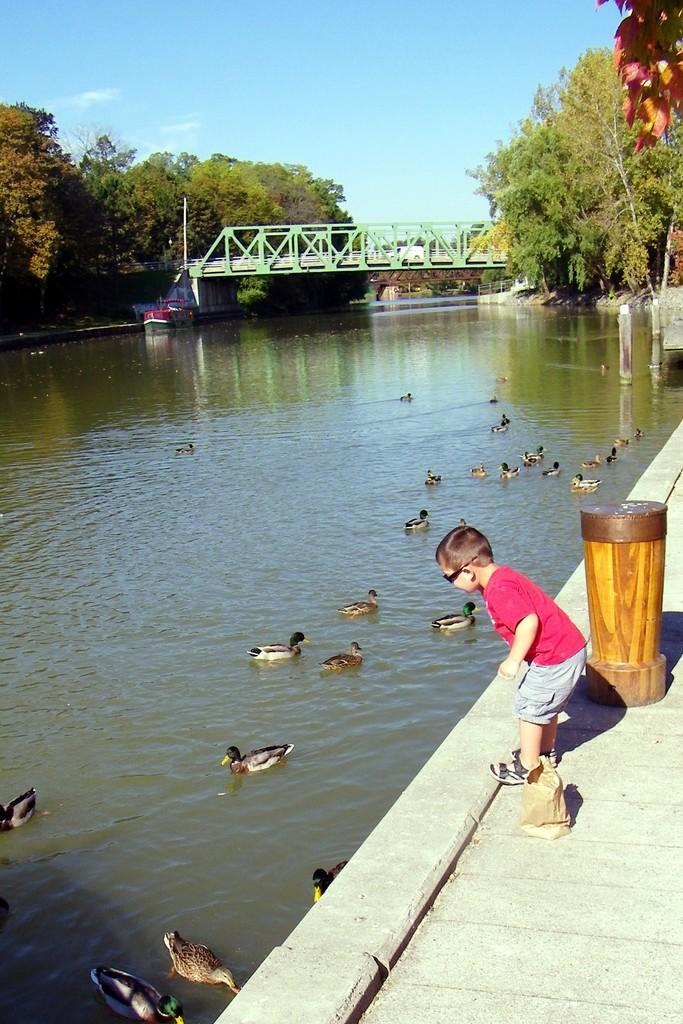What is the main subject of the image? The main subject of the image is a boat. What can be seen on the water near the boat? There are swans on the water. What is visible in the background of the image? There are trees, a bridge, a kid wearing glasses, and a pole on the ground in the background of the image. What type of quilt is being used to cover the swans in the image? There is no quilt present in the image; the swans are on the water without any covering. Can you tell me how many gloves the kid in the background is wearing? There is no mention of gloves in the image; the kid is wearing glasses, but no gloves are visible. 